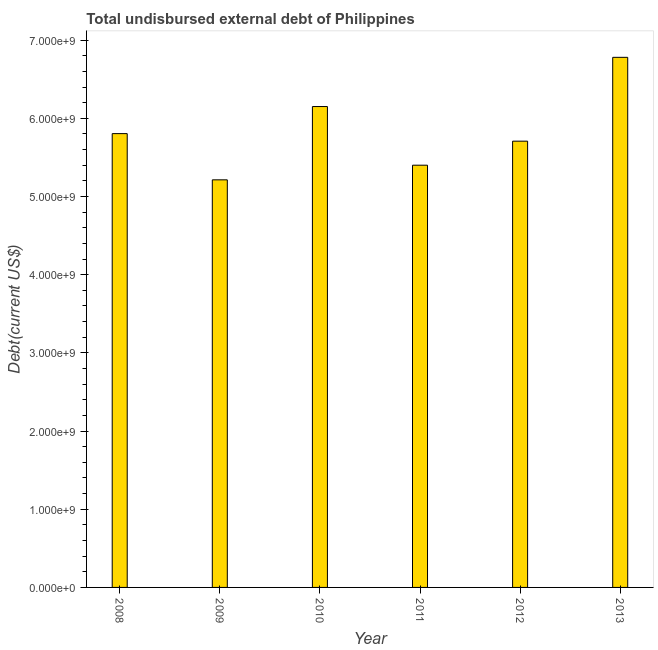What is the title of the graph?
Provide a short and direct response. Total undisbursed external debt of Philippines. What is the label or title of the X-axis?
Offer a very short reply. Year. What is the label or title of the Y-axis?
Your answer should be compact. Debt(current US$). What is the total debt in 2009?
Ensure brevity in your answer.  5.21e+09. Across all years, what is the maximum total debt?
Offer a very short reply. 6.78e+09. Across all years, what is the minimum total debt?
Your response must be concise. 5.21e+09. In which year was the total debt maximum?
Give a very brief answer. 2013. In which year was the total debt minimum?
Provide a succinct answer. 2009. What is the sum of the total debt?
Provide a succinct answer. 3.51e+1. What is the difference between the total debt in 2010 and 2012?
Ensure brevity in your answer.  4.43e+08. What is the average total debt per year?
Offer a very short reply. 5.84e+09. What is the median total debt?
Provide a short and direct response. 5.76e+09. In how many years, is the total debt greater than 1600000000 US$?
Offer a very short reply. 6. Do a majority of the years between 2008 and 2010 (inclusive) have total debt greater than 4200000000 US$?
Offer a very short reply. Yes. What is the ratio of the total debt in 2011 to that in 2012?
Your response must be concise. 0.95. Is the total debt in 2008 less than that in 2013?
Your response must be concise. Yes. Is the difference between the total debt in 2012 and 2013 greater than the difference between any two years?
Make the answer very short. No. What is the difference between the highest and the second highest total debt?
Provide a succinct answer. 6.29e+08. Is the sum of the total debt in 2008 and 2013 greater than the maximum total debt across all years?
Offer a terse response. Yes. What is the difference between the highest and the lowest total debt?
Offer a terse response. 1.57e+09. In how many years, is the total debt greater than the average total debt taken over all years?
Your answer should be very brief. 2. Are all the bars in the graph horizontal?
Provide a succinct answer. No. How many years are there in the graph?
Offer a very short reply. 6. What is the Debt(current US$) in 2008?
Give a very brief answer. 5.80e+09. What is the Debt(current US$) of 2009?
Offer a very short reply. 5.21e+09. What is the Debt(current US$) of 2010?
Give a very brief answer. 6.15e+09. What is the Debt(current US$) of 2011?
Offer a very short reply. 5.40e+09. What is the Debt(current US$) of 2012?
Your answer should be compact. 5.71e+09. What is the Debt(current US$) of 2013?
Provide a succinct answer. 6.78e+09. What is the difference between the Debt(current US$) in 2008 and 2009?
Offer a very short reply. 5.91e+08. What is the difference between the Debt(current US$) in 2008 and 2010?
Your answer should be compact. -3.46e+08. What is the difference between the Debt(current US$) in 2008 and 2011?
Your answer should be very brief. 4.04e+08. What is the difference between the Debt(current US$) in 2008 and 2012?
Offer a terse response. 9.64e+07. What is the difference between the Debt(current US$) in 2008 and 2013?
Offer a very short reply. -9.76e+08. What is the difference between the Debt(current US$) in 2009 and 2010?
Your answer should be very brief. -9.38e+08. What is the difference between the Debt(current US$) in 2009 and 2011?
Your response must be concise. -1.87e+08. What is the difference between the Debt(current US$) in 2009 and 2012?
Your answer should be very brief. -4.95e+08. What is the difference between the Debt(current US$) in 2009 and 2013?
Offer a very short reply. -1.57e+09. What is the difference between the Debt(current US$) in 2010 and 2011?
Give a very brief answer. 7.50e+08. What is the difference between the Debt(current US$) in 2010 and 2012?
Your response must be concise. 4.43e+08. What is the difference between the Debt(current US$) in 2010 and 2013?
Make the answer very short. -6.29e+08. What is the difference between the Debt(current US$) in 2011 and 2012?
Keep it short and to the point. -3.07e+08. What is the difference between the Debt(current US$) in 2011 and 2013?
Offer a terse response. -1.38e+09. What is the difference between the Debt(current US$) in 2012 and 2013?
Provide a short and direct response. -1.07e+09. What is the ratio of the Debt(current US$) in 2008 to that in 2009?
Ensure brevity in your answer.  1.11. What is the ratio of the Debt(current US$) in 2008 to that in 2010?
Give a very brief answer. 0.94. What is the ratio of the Debt(current US$) in 2008 to that in 2011?
Ensure brevity in your answer.  1.07. What is the ratio of the Debt(current US$) in 2008 to that in 2012?
Ensure brevity in your answer.  1.02. What is the ratio of the Debt(current US$) in 2008 to that in 2013?
Your response must be concise. 0.86. What is the ratio of the Debt(current US$) in 2009 to that in 2010?
Ensure brevity in your answer.  0.85. What is the ratio of the Debt(current US$) in 2009 to that in 2013?
Provide a short and direct response. 0.77. What is the ratio of the Debt(current US$) in 2010 to that in 2011?
Provide a succinct answer. 1.14. What is the ratio of the Debt(current US$) in 2010 to that in 2012?
Give a very brief answer. 1.08. What is the ratio of the Debt(current US$) in 2010 to that in 2013?
Your response must be concise. 0.91. What is the ratio of the Debt(current US$) in 2011 to that in 2012?
Keep it short and to the point. 0.95. What is the ratio of the Debt(current US$) in 2011 to that in 2013?
Make the answer very short. 0.8. What is the ratio of the Debt(current US$) in 2012 to that in 2013?
Offer a terse response. 0.84. 